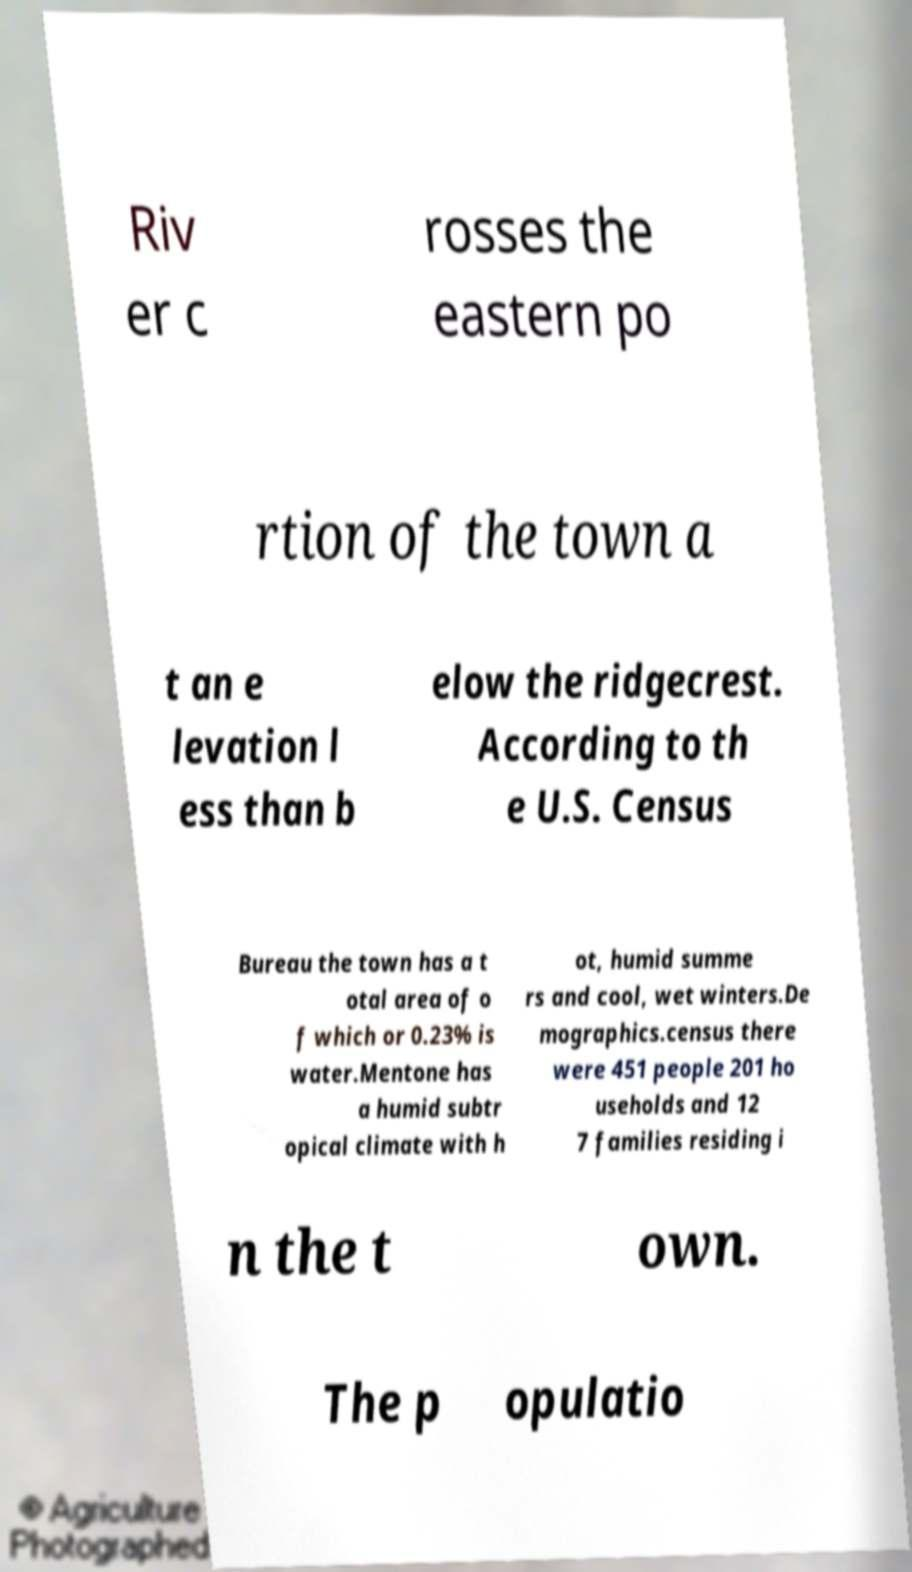Please read and relay the text visible in this image. What does it say? Riv er c rosses the eastern po rtion of the town a t an e levation l ess than b elow the ridgecrest. According to th e U.S. Census Bureau the town has a t otal area of o f which or 0.23% is water.Mentone has a humid subtr opical climate with h ot, humid summe rs and cool, wet winters.De mographics.census there were 451 people 201 ho useholds and 12 7 families residing i n the t own. The p opulatio 